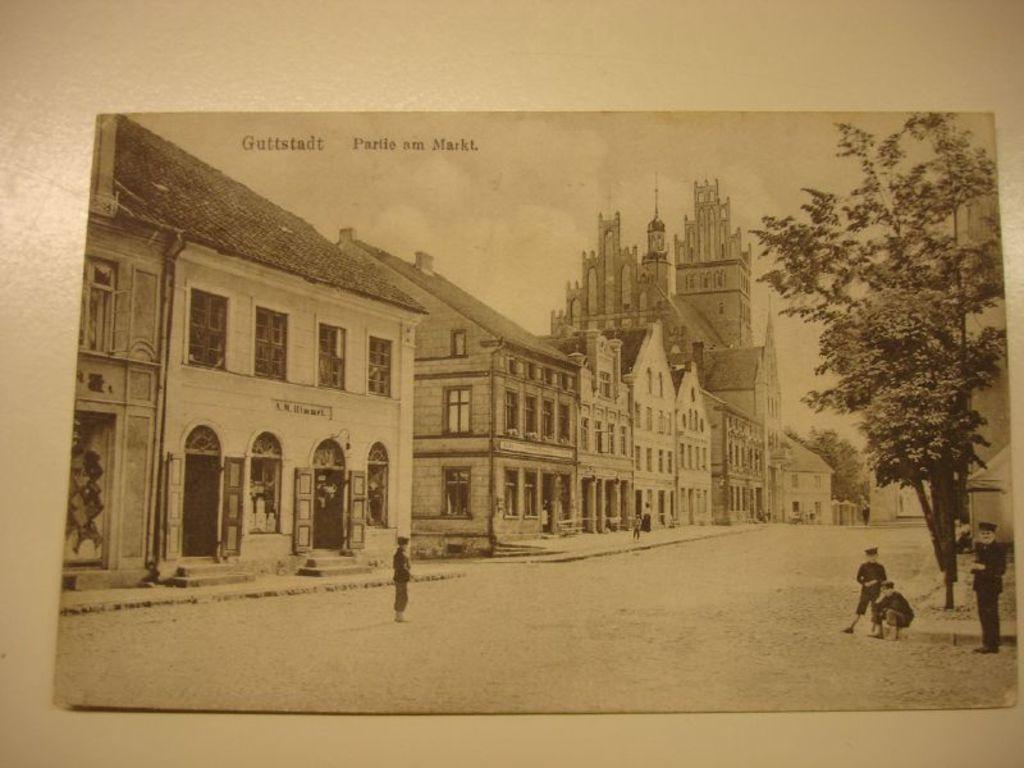What is the main object in the image? There is a card in the image. Where is the card located? The card is placed on a surface. What can be seen on the card? The card contains a black and white picture. What is depicted in the picture? The picture depicts some buildings and people on the ground. What else can be seen in the picture? Trees and the sky are visible in the picture. How does the wave affect the card in the image? There is no wave present in the image, so it cannot affect the card. 